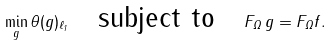Convert formula to latex. <formula><loc_0><loc_0><loc_500><loc_500>\min _ { g } \| \theta ( g ) \| _ { \ell _ { 1 } } \quad \text {subject to} \quad F _ { \Omega } \, g = F _ { \Omega } f .</formula> 